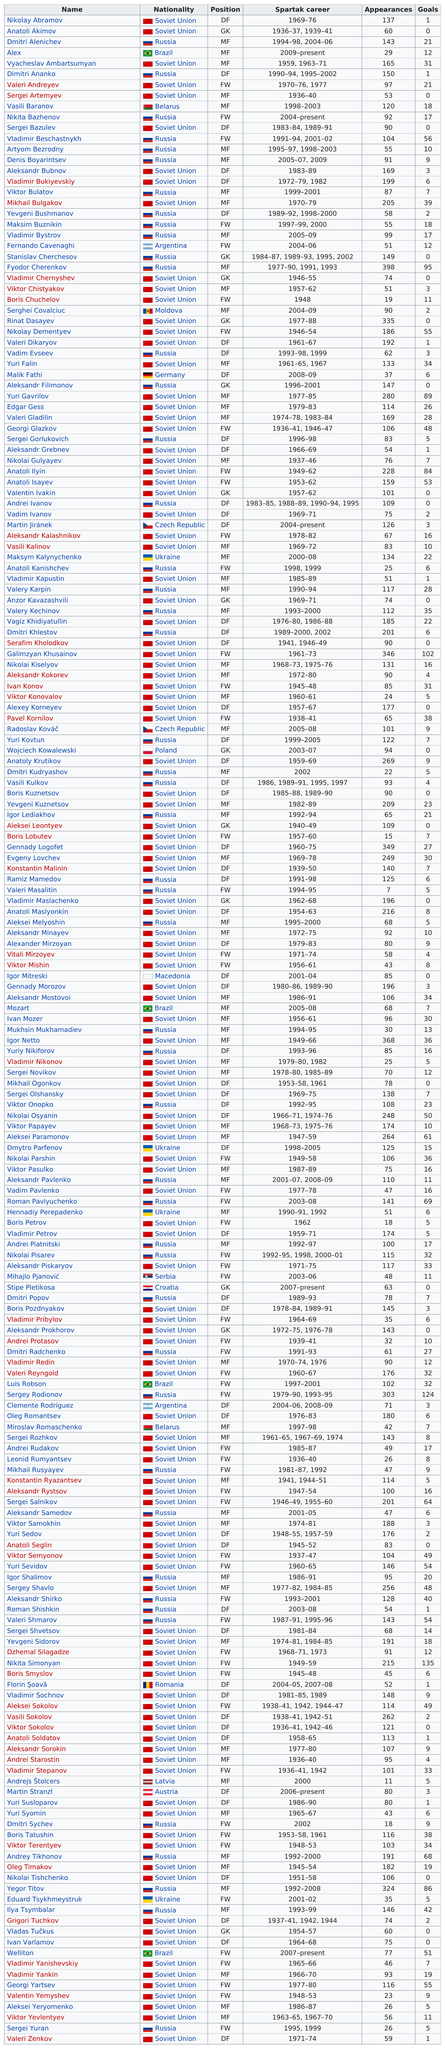Give some essential details in this illustration. Vladimir Bukirevskiy had 199 appearances. 56 players achieved at least 20 league goals in their respective seasons. Fyodor Cherenkov had the highest number of appearances. Fyodor Cherenkov is the player with the most appearances for the club, with a record of accomplishment that speaks for itself. With a total of 14 goals, Nikita Simonyan is the player with the highest number of goals in the game. 